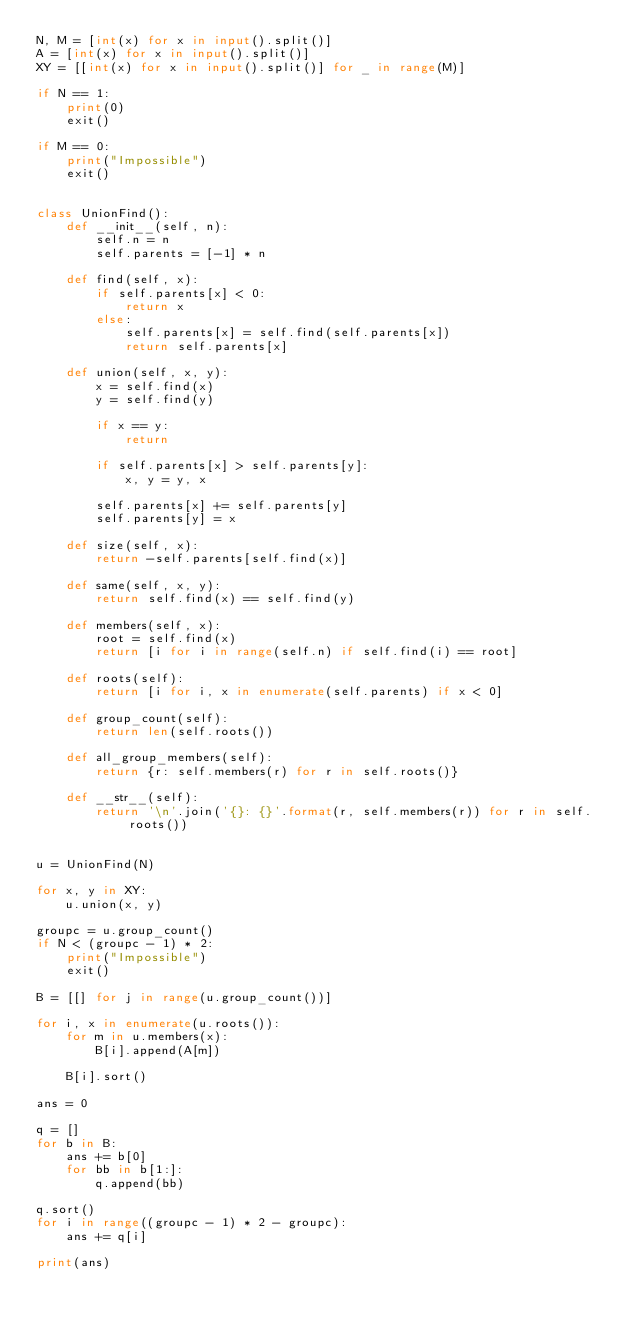Convert code to text. <code><loc_0><loc_0><loc_500><loc_500><_Python_>N, M = [int(x) for x in input().split()]
A = [int(x) for x in input().split()]
XY = [[int(x) for x in input().split()] for _ in range(M)]

if N == 1:
    print(0)
    exit()

if M == 0:
    print("Impossible")
    exit()


class UnionFind():
    def __init__(self, n):
        self.n = n
        self.parents = [-1] * n

    def find(self, x):
        if self.parents[x] < 0:
            return x
        else:
            self.parents[x] = self.find(self.parents[x])
            return self.parents[x]

    def union(self, x, y):
        x = self.find(x)
        y = self.find(y)

        if x == y:
            return

        if self.parents[x] > self.parents[y]:
            x, y = y, x

        self.parents[x] += self.parents[y]
        self.parents[y] = x

    def size(self, x):
        return -self.parents[self.find(x)]

    def same(self, x, y):
        return self.find(x) == self.find(y)

    def members(self, x):
        root = self.find(x)
        return [i for i in range(self.n) if self.find(i) == root]

    def roots(self):
        return [i for i, x in enumerate(self.parents) if x < 0]

    def group_count(self):
        return len(self.roots())

    def all_group_members(self):
        return {r: self.members(r) for r in self.roots()}

    def __str__(self):
        return '\n'.join('{}: {}'.format(r, self.members(r)) for r in self.roots())


u = UnionFind(N)

for x, y in XY:
    u.union(x, y)

groupc = u.group_count()
if N < (groupc - 1) * 2:
    print("Impossible")
    exit()

B = [[] for j in range(u.group_count())]

for i, x in enumerate(u.roots()):
    for m in u.members(x):
        B[i].append(A[m])

    B[i].sort()

ans = 0

q = []
for b in B:
    ans += b[0]
    for bb in b[1:]:
        q.append(bb)

q.sort()
for i in range((groupc - 1) * 2 - groupc):
    ans += q[i]

print(ans)

</code> 